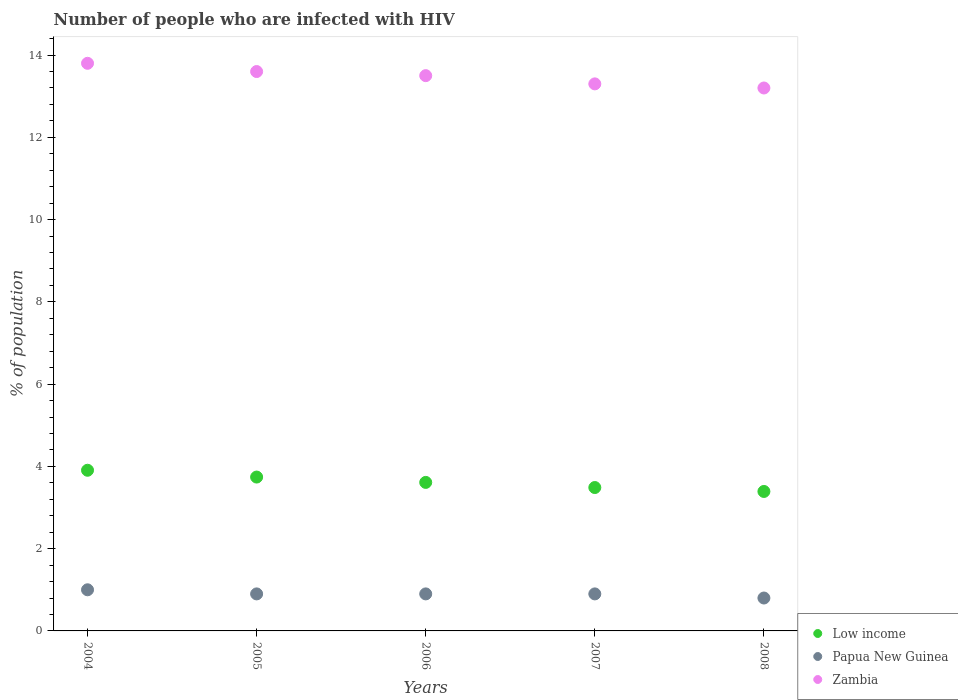What is the percentage of HIV infected population in in Zambia in 2008?
Your answer should be compact. 13.2. Across all years, what is the maximum percentage of HIV infected population in in Low income?
Make the answer very short. 3.91. Across all years, what is the minimum percentage of HIV infected population in in Papua New Guinea?
Offer a very short reply. 0.8. What is the total percentage of HIV infected population in in Papua New Guinea in the graph?
Your response must be concise. 4.5. What is the difference between the percentage of HIV infected population in in Zambia in 2006 and that in 2007?
Offer a terse response. 0.2. What is the average percentage of HIV infected population in in Zambia per year?
Your answer should be compact. 13.48. In the year 2007, what is the difference between the percentage of HIV infected population in in Low income and percentage of HIV infected population in in Papua New Guinea?
Provide a succinct answer. 2.59. What is the ratio of the percentage of HIV infected population in in Zambia in 2004 to that in 2007?
Offer a very short reply. 1.04. Is the percentage of HIV infected population in in Low income in 2004 less than that in 2008?
Give a very brief answer. No. Is the difference between the percentage of HIV infected population in in Low income in 2004 and 2007 greater than the difference between the percentage of HIV infected population in in Papua New Guinea in 2004 and 2007?
Your answer should be very brief. Yes. What is the difference between the highest and the second highest percentage of HIV infected population in in Low income?
Your response must be concise. 0.17. What is the difference between the highest and the lowest percentage of HIV infected population in in Zambia?
Make the answer very short. 0.6. Is the sum of the percentage of HIV infected population in in Low income in 2005 and 2008 greater than the maximum percentage of HIV infected population in in Papua New Guinea across all years?
Give a very brief answer. Yes. Is it the case that in every year, the sum of the percentage of HIV infected population in in Low income and percentage of HIV infected population in in Papua New Guinea  is greater than the percentage of HIV infected population in in Zambia?
Provide a short and direct response. No. Does the percentage of HIV infected population in in Zambia monotonically increase over the years?
Your answer should be very brief. No. Is the percentage of HIV infected population in in Low income strictly greater than the percentage of HIV infected population in in Zambia over the years?
Your response must be concise. No. Is the percentage of HIV infected population in in Low income strictly less than the percentage of HIV infected population in in Zambia over the years?
Offer a very short reply. Yes. How many years are there in the graph?
Your answer should be very brief. 5. Are the values on the major ticks of Y-axis written in scientific E-notation?
Your response must be concise. No. How are the legend labels stacked?
Provide a short and direct response. Vertical. What is the title of the graph?
Your response must be concise. Number of people who are infected with HIV. Does "Swaziland" appear as one of the legend labels in the graph?
Your response must be concise. No. What is the label or title of the Y-axis?
Offer a terse response. % of population. What is the % of population in Low income in 2004?
Your answer should be very brief. 3.91. What is the % of population of Papua New Guinea in 2004?
Give a very brief answer. 1. What is the % of population of Low income in 2005?
Your answer should be very brief. 3.74. What is the % of population of Papua New Guinea in 2005?
Your answer should be very brief. 0.9. What is the % of population of Low income in 2006?
Provide a succinct answer. 3.61. What is the % of population in Papua New Guinea in 2006?
Your answer should be compact. 0.9. What is the % of population in Low income in 2007?
Offer a terse response. 3.49. What is the % of population in Papua New Guinea in 2007?
Your response must be concise. 0.9. What is the % of population of Low income in 2008?
Give a very brief answer. 3.39. What is the % of population in Papua New Guinea in 2008?
Offer a terse response. 0.8. What is the % of population of Zambia in 2008?
Offer a terse response. 13.2. Across all years, what is the maximum % of population in Low income?
Ensure brevity in your answer.  3.91. Across all years, what is the maximum % of population of Zambia?
Provide a succinct answer. 13.8. Across all years, what is the minimum % of population in Low income?
Offer a very short reply. 3.39. What is the total % of population of Low income in the graph?
Make the answer very short. 18.13. What is the total % of population of Papua New Guinea in the graph?
Your answer should be compact. 4.5. What is the total % of population of Zambia in the graph?
Offer a terse response. 67.4. What is the difference between the % of population in Low income in 2004 and that in 2005?
Make the answer very short. 0.17. What is the difference between the % of population of Papua New Guinea in 2004 and that in 2005?
Keep it short and to the point. 0.1. What is the difference between the % of population in Low income in 2004 and that in 2006?
Offer a terse response. 0.3. What is the difference between the % of population in Papua New Guinea in 2004 and that in 2006?
Your answer should be very brief. 0.1. What is the difference between the % of population in Zambia in 2004 and that in 2006?
Offer a very short reply. 0.3. What is the difference between the % of population in Low income in 2004 and that in 2007?
Offer a very short reply. 0.42. What is the difference between the % of population in Zambia in 2004 and that in 2007?
Your answer should be compact. 0.5. What is the difference between the % of population in Low income in 2004 and that in 2008?
Offer a terse response. 0.52. What is the difference between the % of population in Low income in 2005 and that in 2006?
Offer a very short reply. 0.13. What is the difference between the % of population in Low income in 2005 and that in 2007?
Provide a short and direct response. 0.25. What is the difference between the % of population of Zambia in 2005 and that in 2008?
Keep it short and to the point. 0.4. What is the difference between the % of population in Low income in 2006 and that in 2007?
Provide a succinct answer. 0.12. What is the difference between the % of population in Papua New Guinea in 2006 and that in 2007?
Your response must be concise. 0. What is the difference between the % of population in Low income in 2006 and that in 2008?
Offer a very short reply. 0.22. What is the difference between the % of population of Papua New Guinea in 2006 and that in 2008?
Keep it short and to the point. 0.1. What is the difference between the % of population in Low income in 2007 and that in 2008?
Your answer should be compact. 0.1. What is the difference between the % of population in Zambia in 2007 and that in 2008?
Keep it short and to the point. 0.1. What is the difference between the % of population in Low income in 2004 and the % of population in Papua New Guinea in 2005?
Make the answer very short. 3.01. What is the difference between the % of population of Low income in 2004 and the % of population of Zambia in 2005?
Your answer should be compact. -9.69. What is the difference between the % of population in Papua New Guinea in 2004 and the % of population in Zambia in 2005?
Provide a short and direct response. -12.6. What is the difference between the % of population of Low income in 2004 and the % of population of Papua New Guinea in 2006?
Make the answer very short. 3.01. What is the difference between the % of population in Low income in 2004 and the % of population in Zambia in 2006?
Provide a succinct answer. -9.59. What is the difference between the % of population in Low income in 2004 and the % of population in Papua New Guinea in 2007?
Make the answer very short. 3.01. What is the difference between the % of population in Low income in 2004 and the % of population in Zambia in 2007?
Make the answer very short. -9.39. What is the difference between the % of population of Papua New Guinea in 2004 and the % of population of Zambia in 2007?
Offer a very short reply. -12.3. What is the difference between the % of population of Low income in 2004 and the % of population of Papua New Guinea in 2008?
Your answer should be very brief. 3.11. What is the difference between the % of population in Low income in 2004 and the % of population in Zambia in 2008?
Make the answer very short. -9.29. What is the difference between the % of population in Papua New Guinea in 2004 and the % of population in Zambia in 2008?
Make the answer very short. -12.2. What is the difference between the % of population of Low income in 2005 and the % of population of Papua New Guinea in 2006?
Offer a terse response. 2.84. What is the difference between the % of population in Low income in 2005 and the % of population in Zambia in 2006?
Provide a succinct answer. -9.76. What is the difference between the % of population in Papua New Guinea in 2005 and the % of population in Zambia in 2006?
Keep it short and to the point. -12.6. What is the difference between the % of population of Low income in 2005 and the % of population of Papua New Guinea in 2007?
Make the answer very short. 2.84. What is the difference between the % of population in Low income in 2005 and the % of population in Zambia in 2007?
Offer a very short reply. -9.56. What is the difference between the % of population in Papua New Guinea in 2005 and the % of population in Zambia in 2007?
Keep it short and to the point. -12.4. What is the difference between the % of population in Low income in 2005 and the % of population in Papua New Guinea in 2008?
Give a very brief answer. 2.94. What is the difference between the % of population of Low income in 2005 and the % of population of Zambia in 2008?
Keep it short and to the point. -9.46. What is the difference between the % of population of Low income in 2006 and the % of population of Papua New Guinea in 2007?
Offer a terse response. 2.71. What is the difference between the % of population in Low income in 2006 and the % of population in Zambia in 2007?
Give a very brief answer. -9.69. What is the difference between the % of population in Papua New Guinea in 2006 and the % of population in Zambia in 2007?
Make the answer very short. -12.4. What is the difference between the % of population of Low income in 2006 and the % of population of Papua New Guinea in 2008?
Offer a terse response. 2.81. What is the difference between the % of population in Low income in 2006 and the % of population in Zambia in 2008?
Provide a succinct answer. -9.59. What is the difference between the % of population in Papua New Guinea in 2006 and the % of population in Zambia in 2008?
Keep it short and to the point. -12.3. What is the difference between the % of population of Low income in 2007 and the % of population of Papua New Guinea in 2008?
Offer a terse response. 2.69. What is the difference between the % of population of Low income in 2007 and the % of population of Zambia in 2008?
Provide a succinct answer. -9.71. What is the average % of population in Low income per year?
Offer a very short reply. 3.63. What is the average % of population of Zambia per year?
Provide a succinct answer. 13.48. In the year 2004, what is the difference between the % of population in Low income and % of population in Papua New Guinea?
Offer a terse response. 2.91. In the year 2004, what is the difference between the % of population of Low income and % of population of Zambia?
Your answer should be very brief. -9.89. In the year 2004, what is the difference between the % of population of Papua New Guinea and % of population of Zambia?
Offer a very short reply. -12.8. In the year 2005, what is the difference between the % of population of Low income and % of population of Papua New Guinea?
Make the answer very short. 2.84. In the year 2005, what is the difference between the % of population of Low income and % of population of Zambia?
Give a very brief answer. -9.86. In the year 2005, what is the difference between the % of population in Papua New Guinea and % of population in Zambia?
Your answer should be compact. -12.7. In the year 2006, what is the difference between the % of population in Low income and % of population in Papua New Guinea?
Your response must be concise. 2.71. In the year 2006, what is the difference between the % of population of Low income and % of population of Zambia?
Make the answer very short. -9.89. In the year 2007, what is the difference between the % of population of Low income and % of population of Papua New Guinea?
Offer a terse response. 2.59. In the year 2007, what is the difference between the % of population of Low income and % of population of Zambia?
Your answer should be compact. -9.81. In the year 2007, what is the difference between the % of population of Papua New Guinea and % of population of Zambia?
Your answer should be compact. -12.4. In the year 2008, what is the difference between the % of population of Low income and % of population of Papua New Guinea?
Make the answer very short. 2.59. In the year 2008, what is the difference between the % of population in Low income and % of population in Zambia?
Provide a succinct answer. -9.81. What is the ratio of the % of population of Low income in 2004 to that in 2005?
Give a very brief answer. 1.04. What is the ratio of the % of population in Papua New Guinea in 2004 to that in 2005?
Offer a very short reply. 1.11. What is the ratio of the % of population in Zambia in 2004 to that in 2005?
Give a very brief answer. 1.01. What is the ratio of the % of population of Low income in 2004 to that in 2006?
Ensure brevity in your answer.  1.08. What is the ratio of the % of population in Papua New Guinea in 2004 to that in 2006?
Offer a terse response. 1.11. What is the ratio of the % of population of Zambia in 2004 to that in 2006?
Give a very brief answer. 1.02. What is the ratio of the % of population in Low income in 2004 to that in 2007?
Your answer should be very brief. 1.12. What is the ratio of the % of population of Zambia in 2004 to that in 2007?
Make the answer very short. 1.04. What is the ratio of the % of population of Low income in 2004 to that in 2008?
Offer a very short reply. 1.15. What is the ratio of the % of population of Zambia in 2004 to that in 2008?
Offer a very short reply. 1.05. What is the ratio of the % of population of Low income in 2005 to that in 2006?
Your answer should be compact. 1.04. What is the ratio of the % of population of Zambia in 2005 to that in 2006?
Provide a short and direct response. 1.01. What is the ratio of the % of population in Low income in 2005 to that in 2007?
Offer a very short reply. 1.07. What is the ratio of the % of population of Zambia in 2005 to that in 2007?
Give a very brief answer. 1.02. What is the ratio of the % of population in Low income in 2005 to that in 2008?
Your answer should be very brief. 1.1. What is the ratio of the % of population of Papua New Guinea in 2005 to that in 2008?
Keep it short and to the point. 1.12. What is the ratio of the % of population in Zambia in 2005 to that in 2008?
Offer a terse response. 1.03. What is the ratio of the % of population in Low income in 2006 to that in 2007?
Ensure brevity in your answer.  1.04. What is the ratio of the % of population of Low income in 2006 to that in 2008?
Offer a terse response. 1.06. What is the ratio of the % of population of Zambia in 2006 to that in 2008?
Your answer should be very brief. 1.02. What is the ratio of the % of population in Low income in 2007 to that in 2008?
Offer a very short reply. 1.03. What is the ratio of the % of population in Papua New Guinea in 2007 to that in 2008?
Make the answer very short. 1.12. What is the ratio of the % of population in Zambia in 2007 to that in 2008?
Your response must be concise. 1.01. What is the difference between the highest and the second highest % of population in Low income?
Your response must be concise. 0.17. What is the difference between the highest and the lowest % of population of Low income?
Your answer should be very brief. 0.52. 